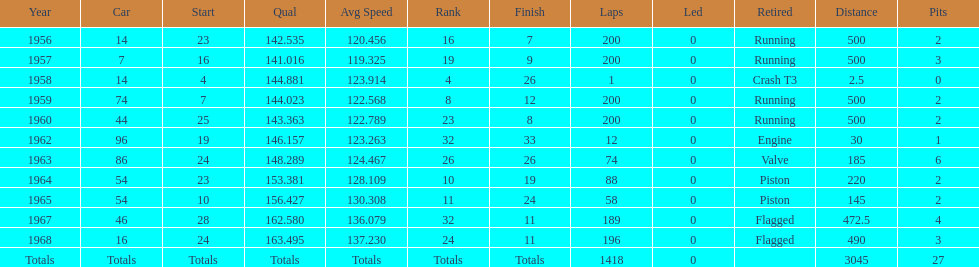What was the last year that it finished the race? 1968. 